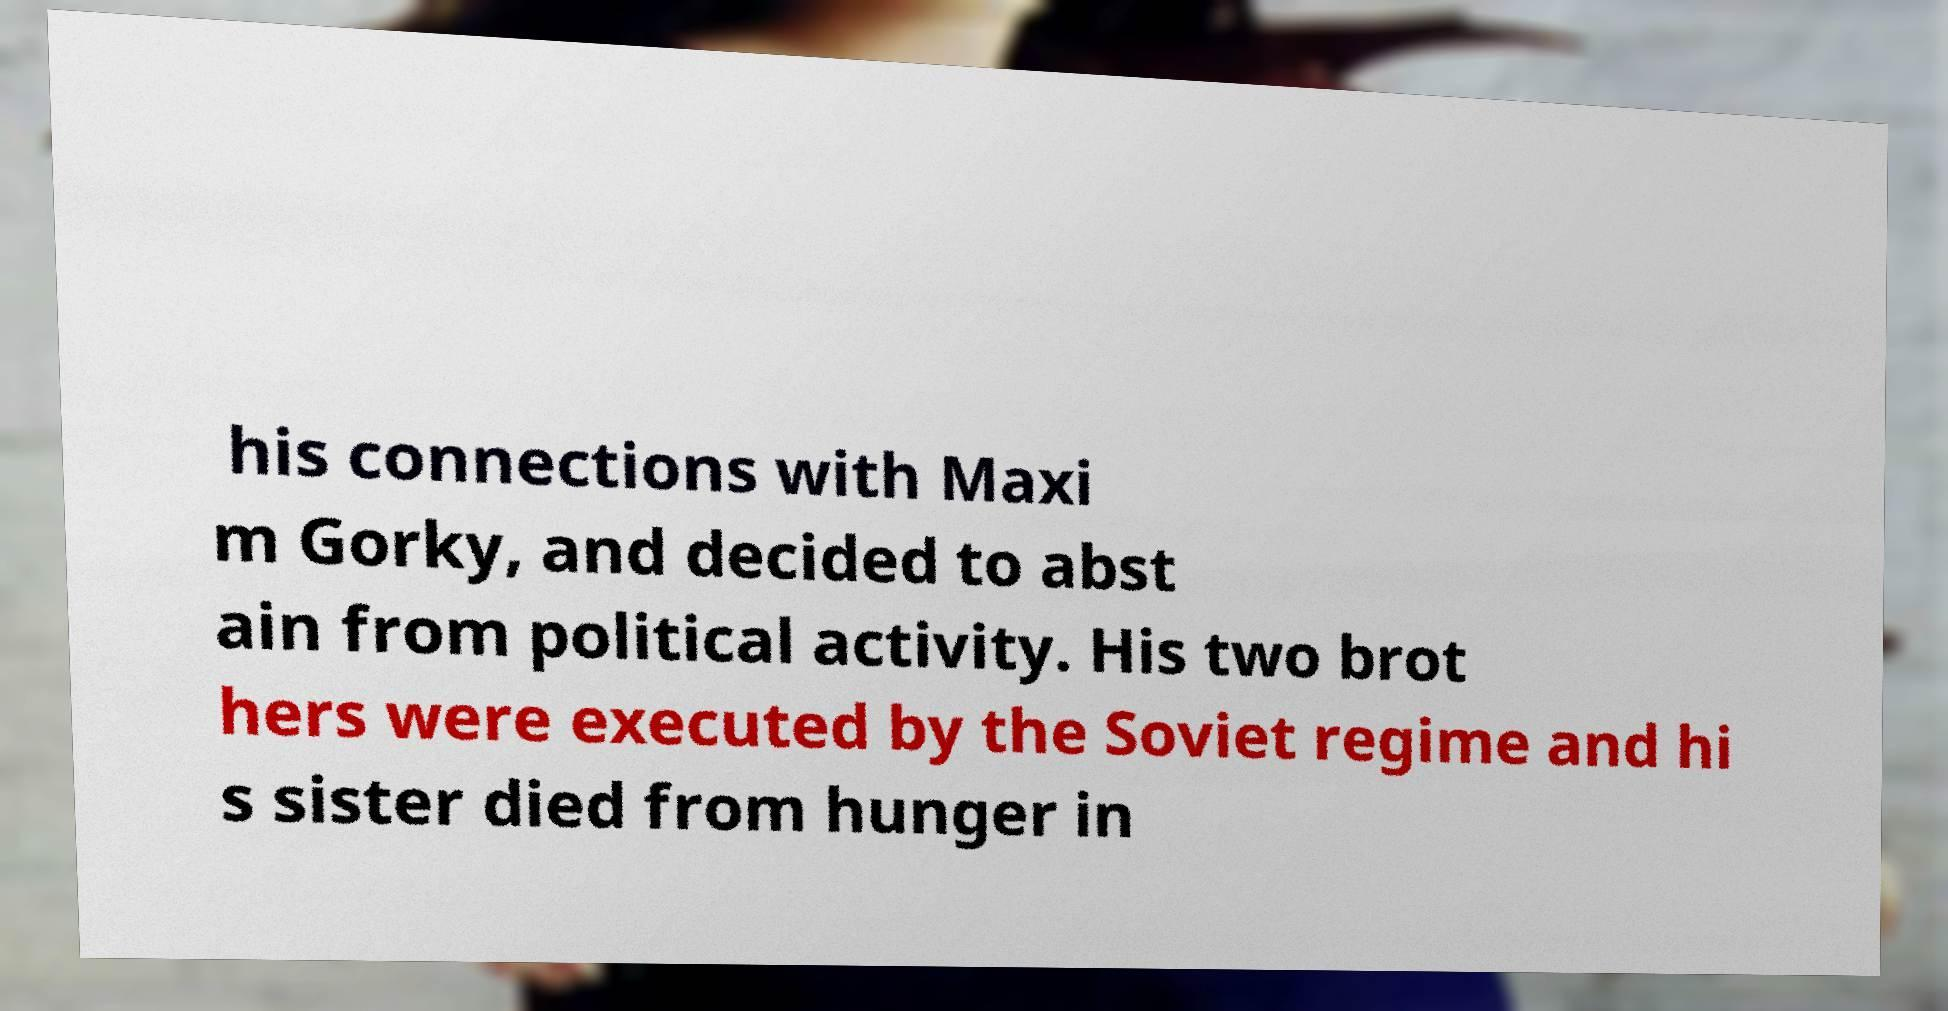Can you accurately transcribe the text from the provided image for me? his connections with Maxi m Gorky, and decided to abst ain from political activity. His two brot hers were executed by the Soviet regime and hi s sister died from hunger in 